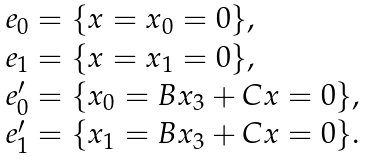<formula> <loc_0><loc_0><loc_500><loc_500>\begin{array} { l } e _ { 0 } = \{ x = x _ { 0 } = 0 \} , \\ e _ { 1 } = \{ x = x _ { 1 } = 0 \} , \\ e ^ { \prime } _ { 0 } = \{ x _ { 0 } = B x _ { 3 } + C x = 0 \} , \\ e ^ { \prime } _ { 1 } = \{ x _ { 1 } = B x _ { 3 } + C x = 0 \} . \end{array}</formula> 